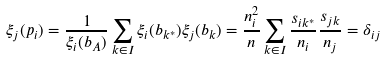Convert formula to latex. <formula><loc_0><loc_0><loc_500><loc_500>\xi _ { j } ( p _ { i } ) = \frac { 1 } { \xi _ { i } ( b _ { A } ) } \sum _ { k \in I } \xi _ { i } ( b _ { k ^ { * } } ) \xi _ { j } ( b _ { k } ) = \frac { n _ { i } ^ { 2 } } { n } \sum _ { k \in I } \frac { s _ { i k ^ { * } } } { n _ { i } } \frac { s _ { j k } } { n _ { j } } = \delta _ { i j }</formula> 